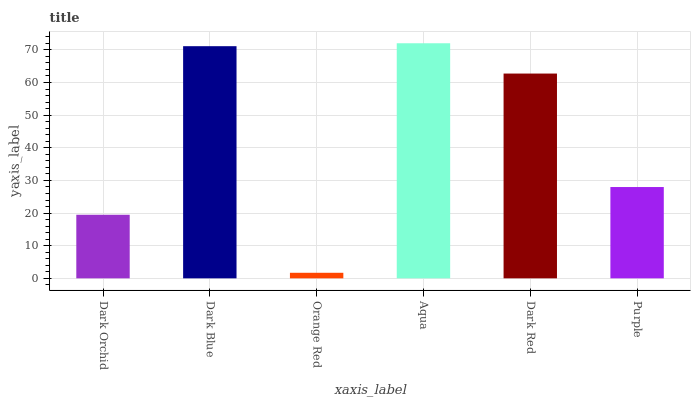Is Orange Red the minimum?
Answer yes or no. Yes. Is Aqua the maximum?
Answer yes or no. Yes. Is Dark Blue the minimum?
Answer yes or no. No. Is Dark Blue the maximum?
Answer yes or no. No. Is Dark Blue greater than Dark Orchid?
Answer yes or no. Yes. Is Dark Orchid less than Dark Blue?
Answer yes or no. Yes. Is Dark Orchid greater than Dark Blue?
Answer yes or no. No. Is Dark Blue less than Dark Orchid?
Answer yes or no. No. Is Dark Red the high median?
Answer yes or no. Yes. Is Purple the low median?
Answer yes or no. Yes. Is Purple the high median?
Answer yes or no. No. Is Dark Orchid the low median?
Answer yes or no. No. 